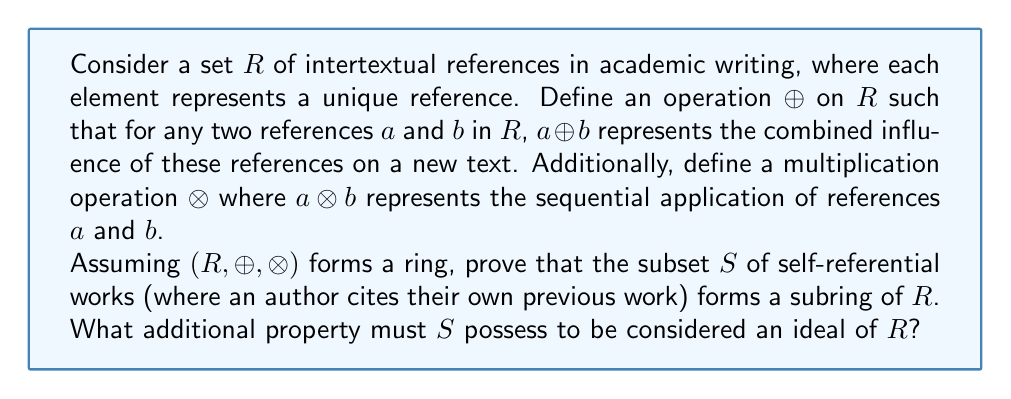Give your solution to this math problem. To prove that $S$ is a subring of $R$ and determine the additional property for it to be an ideal, we need to follow these steps:

1. Prove that $S$ is a subring:
   a) Show that $S$ is closed under $\oplus$:
      For any $a, b \in S$, $a \oplus b \in S$ (as combining two self-references results in a self-reference)
   b) Show that $S$ is closed under $\otimes$:
      For any $a, b \in S$, $a \otimes b \in S$ (sequential application of self-references is still a self-reference)
   c) Show that $S$ contains the additive identity of $R$:
      Let $0_R$ be the additive identity in $R$. Since $0_R \oplus a = a$ for all $a \in R$, $0_R$ must represent "no reference," which is trivially a self-reference. Thus, $0_R \in S$.
   d) Show that $S$ contains additive inverses:
      For any $a \in S$, there exists $-a \in S$ such that $a \oplus (-a) = 0_R$. The inverse of a self-reference is still a self-reference.

2. Additional property for $S$ to be an ideal:
   For $S$ to be an ideal of $R$, it must satisfy the absorption property:
   For all $s \in S$ and $r \in R$, both $s \otimes r \in S$ and $r \otimes s \in S$

This means that when a self-reference is combined (through sequential application) with any other reference, the result must still be considered a self-reference. This property is not inherently true for all subsets of self-references, as combining a self-reference with an external reference could result in a non-self-reference.
Answer: $S$ is a subring of $R$. For $S$ to be an ideal of $R$, it must satisfy the absorption property: $\forall s \in S, \forall r \in R: s \otimes r \in S \text{ and } r \otimes s \in S$. 